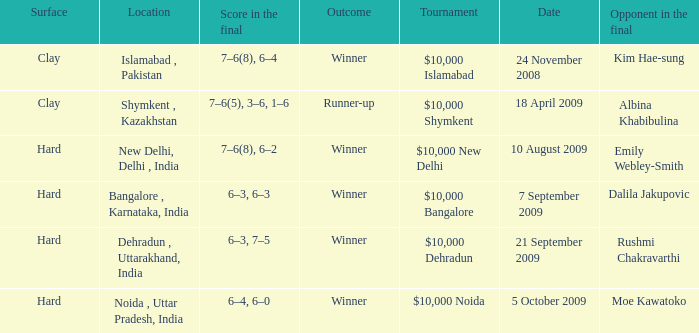In how many dates the opponen in the final was rushmi chakravarthi 1.0. 